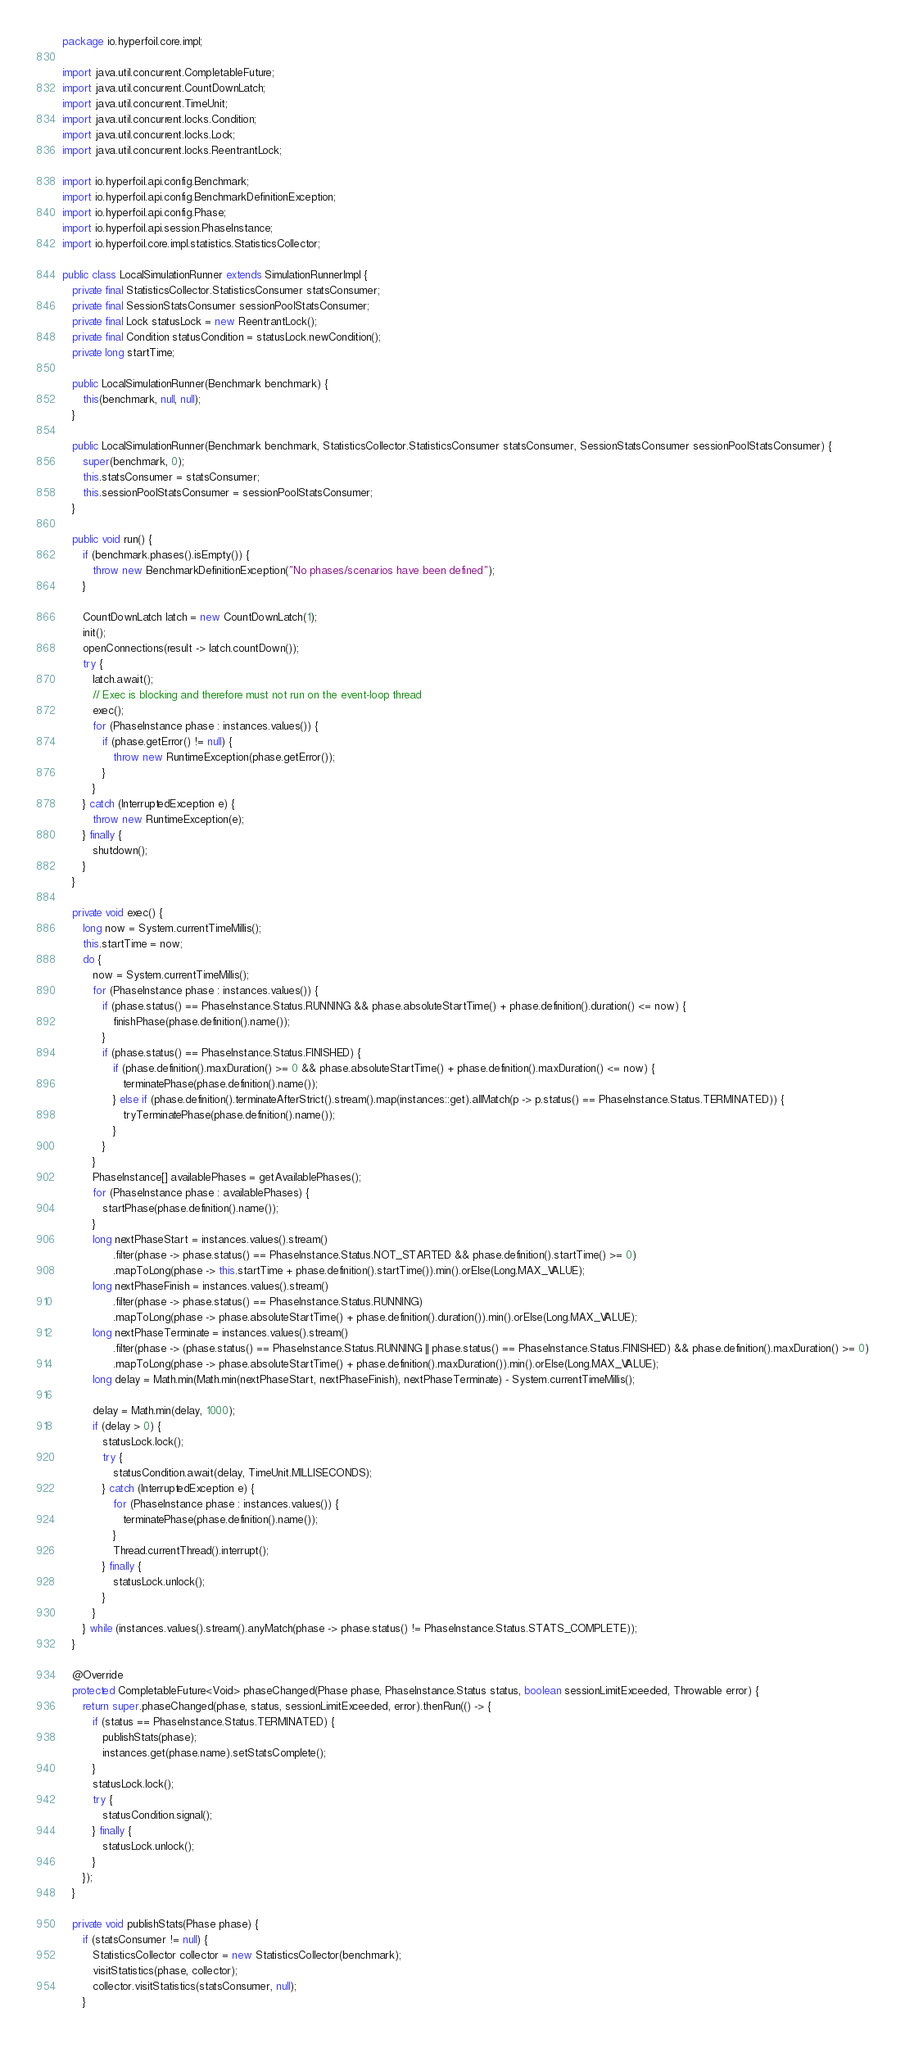Convert code to text. <code><loc_0><loc_0><loc_500><loc_500><_Java_>package io.hyperfoil.core.impl;

import java.util.concurrent.CompletableFuture;
import java.util.concurrent.CountDownLatch;
import java.util.concurrent.TimeUnit;
import java.util.concurrent.locks.Condition;
import java.util.concurrent.locks.Lock;
import java.util.concurrent.locks.ReentrantLock;

import io.hyperfoil.api.config.Benchmark;
import io.hyperfoil.api.config.BenchmarkDefinitionException;
import io.hyperfoil.api.config.Phase;
import io.hyperfoil.api.session.PhaseInstance;
import io.hyperfoil.core.impl.statistics.StatisticsCollector;

public class LocalSimulationRunner extends SimulationRunnerImpl {
   private final StatisticsCollector.StatisticsConsumer statsConsumer;
   private final SessionStatsConsumer sessionPoolStatsConsumer;
   private final Lock statusLock = new ReentrantLock();
   private final Condition statusCondition = statusLock.newCondition();
   private long startTime;

   public LocalSimulationRunner(Benchmark benchmark) {
      this(benchmark, null, null);
   }

   public LocalSimulationRunner(Benchmark benchmark, StatisticsCollector.StatisticsConsumer statsConsumer, SessionStatsConsumer sessionPoolStatsConsumer) {
      super(benchmark, 0);
      this.statsConsumer = statsConsumer;
      this.sessionPoolStatsConsumer = sessionPoolStatsConsumer;
   }

   public void run() {
      if (benchmark.phases().isEmpty()) {
         throw new BenchmarkDefinitionException("No phases/scenarios have been defined");
      }

      CountDownLatch latch = new CountDownLatch(1);
      init();
      openConnections(result -> latch.countDown());
      try {
         latch.await();
         // Exec is blocking and therefore must not run on the event-loop thread
         exec();
         for (PhaseInstance phase : instances.values()) {
            if (phase.getError() != null) {
               throw new RuntimeException(phase.getError());
            }
         }
      } catch (InterruptedException e) {
         throw new RuntimeException(e);
      } finally {
         shutdown();
      }
   }

   private void exec() {
      long now = System.currentTimeMillis();
      this.startTime = now;
      do {
         now = System.currentTimeMillis();
         for (PhaseInstance phase : instances.values()) {
            if (phase.status() == PhaseInstance.Status.RUNNING && phase.absoluteStartTime() + phase.definition().duration() <= now) {
               finishPhase(phase.definition().name());
            }
            if (phase.status() == PhaseInstance.Status.FINISHED) {
               if (phase.definition().maxDuration() >= 0 && phase.absoluteStartTime() + phase.definition().maxDuration() <= now) {
                  terminatePhase(phase.definition().name());
               } else if (phase.definition().terminateAfterStrict().stream().map(instances::get).allMatch(p -> p.status() == PhaseInstance.Status.TERMINATED)) {
                  tryTerminatePhase(phase.definition().name());
               }
            }
         }
         PhaseInstance[] availablePhases = getAvailablePhases();
         for (PhaseInstance phase : availablePhases) {
            startPhase(phase.definition().name());
         }
         long nextPhaseStart = instances.values().stream()
               .filter(phase -> phase.status() == PhaseInstance.Status.NOT_STARTED && phase.definition().startTime() >= 0)
               .mapToLong(phase -> this.startTime + phase.definition().startTime()).min().orElse(Long.MAX_VALUE);
         long nextPhaseFinish = instances.values().stream()
               .filter(phase -> phase.status() == PhaseInstance.Status.RUNNING)
               .mapToLong(phase -> phase.absoluteStartTime() + phase.definition().duration()).min().orElse(Long.MAX_VALUE);
         long nextPhaseTerminate = instances.values().stream()
               .filter(phase -> (phase.status() == PhaseInstance.Status.RUNNING || phase.status() == PhaseInstance.Status.FINISHED) && phase.definition().maxDuration() >= 0)
               .mapToLong(phase -> phase.absoluteStartTime() + phase.definition().maxDuration()).min().orElse(Long.MAX_VALUE);
         long delay = Math.min(Math.min(nextPhaseStart, nextPhaseFinish), nextPhaseTerminate) - System.currentTimeMillis();

         delay = Math.min(delay, 1000);
         if (delay > 0) {
            statusLock.lock();
            try {
               statusCondition.await(delay, TimeUnit.MILLISECONDS);
            } catch (InterruptedException e) {
               for (PhaseInstance phase : instances.values()) {
                  terminatePhase(phase.definition().name());
               }
               Thread.currentThread().interrupt();
            } finally {
               statusLock.unlock();
            }
         }
      } while (instances.values().stream().anyMatch(phase -> phase.status() != PhaseInstance.Status.STATS_COMPLETE));
   }

   @Override
   protected CompletableFuture<Void> phaseChanged(Phase phase, PhaseInstance.Status status, boolean sessionLimitExceeded, Throwable error) {
      return super.phaseChanged(phase, status, sessionLimitExceeded, error).thenRun(() -> {
         if (status == PhaseInstance.Status.TERMINATED) {
            publishStats(phase);
            instances.get(phase.name).setStatsComplete();
         }
         statusLock.lock();
         try {
            statusCondition.signal();
         } finally {
            statusLock.unlock();
         }
      });
   }

   private void publishStats(Phase phase) {
      if (statsConsumer != null) {
         StatisticsCollector collector = new StatisticsCollector(benchmark);
         visitStatistics(phase, collector);
         collector.visitStatistics(statsConsumer, null);
      }</code> 